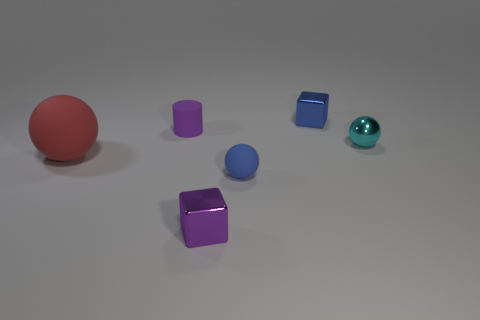Add 4 purple matte cylinders. How many objects exist? 10 Subtract all red rubber spheres. How many spheres are left? 2 Subtract all cubes. How many objects are left? 4 Subtract 1 balls. How many balls are left? 2 Subtract all blue balls. How many balls are left? 2 Subtract 1 purple blocks. How many objects are left? 5 Subtract all yellow cylinders. Subtract all brown spheres. How many cylinders are left? 1 Subtract all red cubes. How many cyan cylinders are left? 0 Subtract all small purple metal things. Subtract all purple matte things. How many objects are left? 4 Add 6 large balls. How many large balls are left? 7 